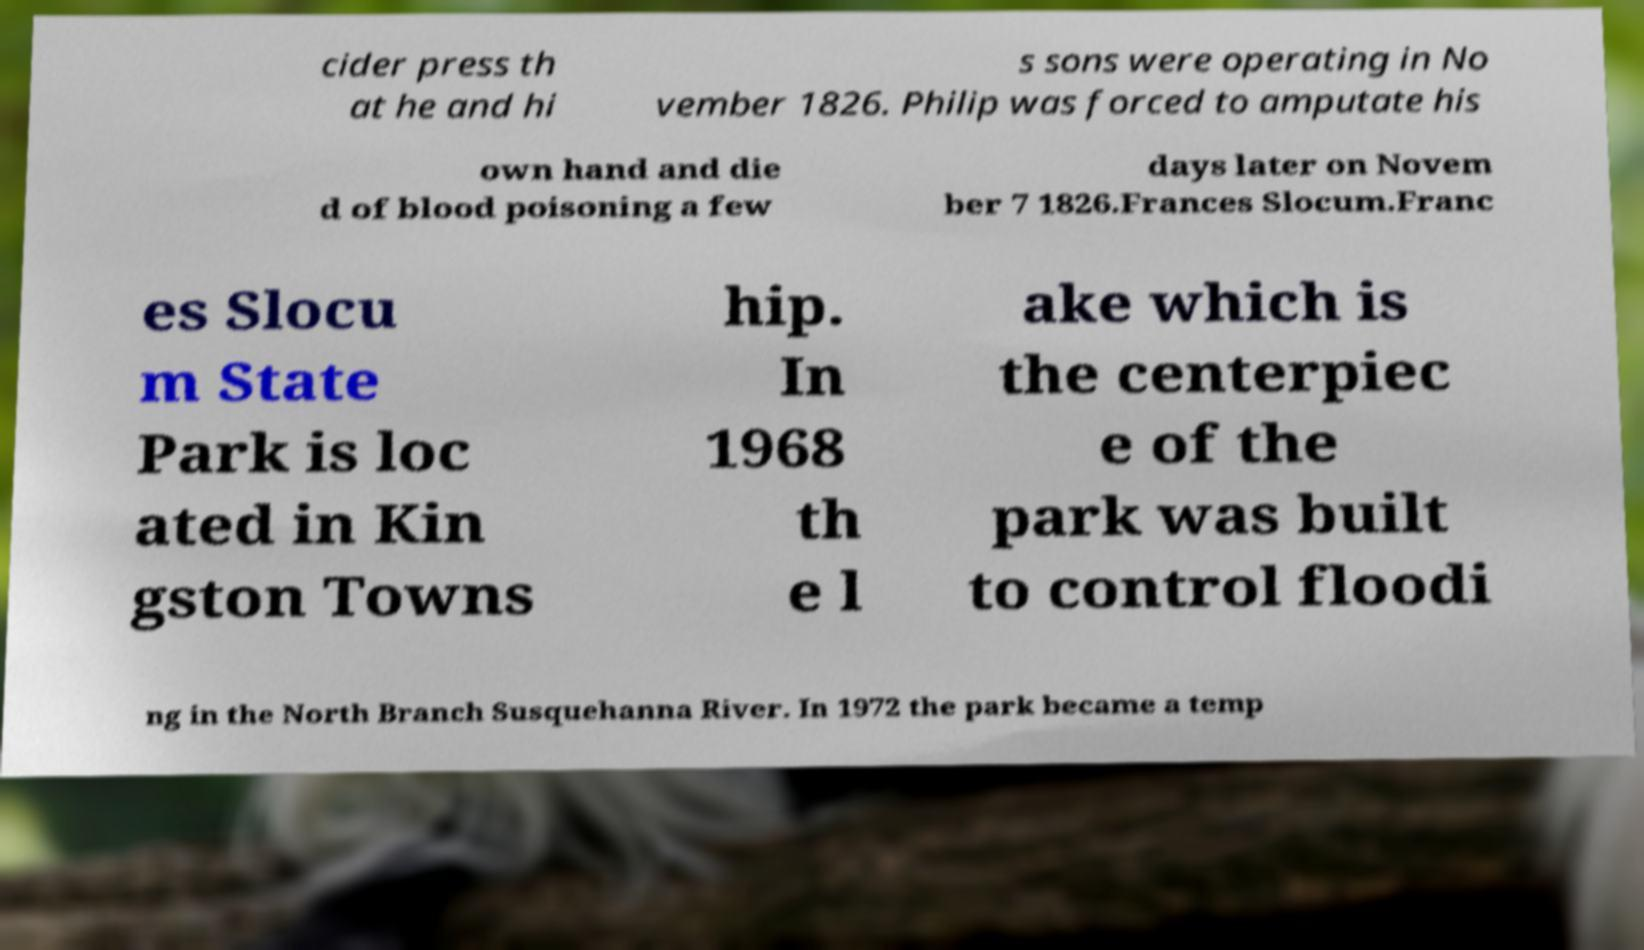For documentation purposes, I need the text within this image transcribed. Could you provide that? cider press th at he and hi s sons were operating in No vember 1826. Philip was forced to amputate his own hand and die d of blood poisoning a few days later on Novem ber 7 1826.Frances Slocum.Franc es Slocu m State Park is loc ated in Kin gston Towns hip. In 1968 th e l ake which is the centerpiec e of the park was built to control floodi ng in the North Branch Susquehanna River. In 1972 the park became a temp 